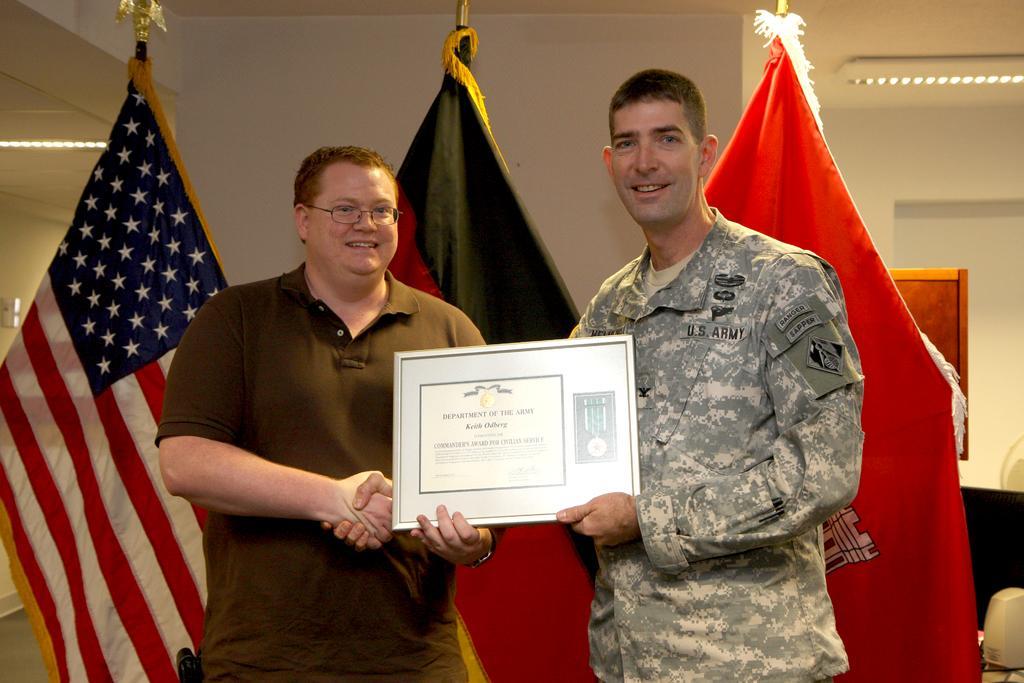Please provide a concise description of this image. In this image we can see two people standing and they both are holding an object. In the background, we can see three flags and we can see the wall. 